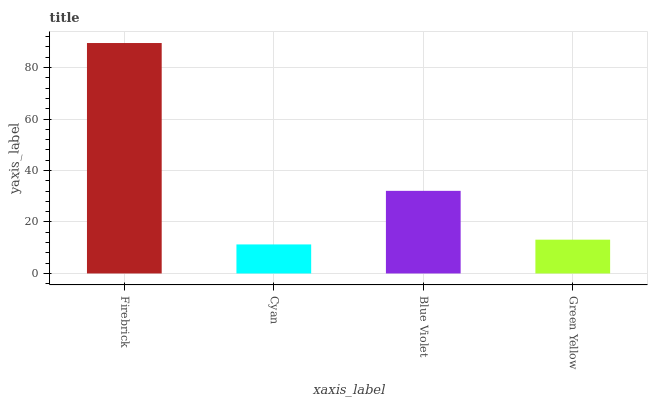Is Cyan the minimum?
Answer yes or no. Yes. Is Firebrick the maximum?
Answer yes or no. Yes. Is Blue Violet the minimum?
Answer yes or no. No. Is Blue Violet the maximum?
Answer yes or no. No. Is Blue Violet greater than Cyan?
Answer yes or no. Yes. Is Cyan less than Blue Violet?
Answer yes or no. Yes. Is Cyan greater than Blue Violet?
Answer yes or no. No. Is Blue Violet less than Cyan?
Answer yes or no. No. Is Blue Violet the high median?
Answer yes or no. Yes. Is Green Yellow the low median?
Answer yes or no. Yes. Is Firebrick the high median?
Answer yes or no. No. Is Cyan the low median?
Answer yes or no. No. 